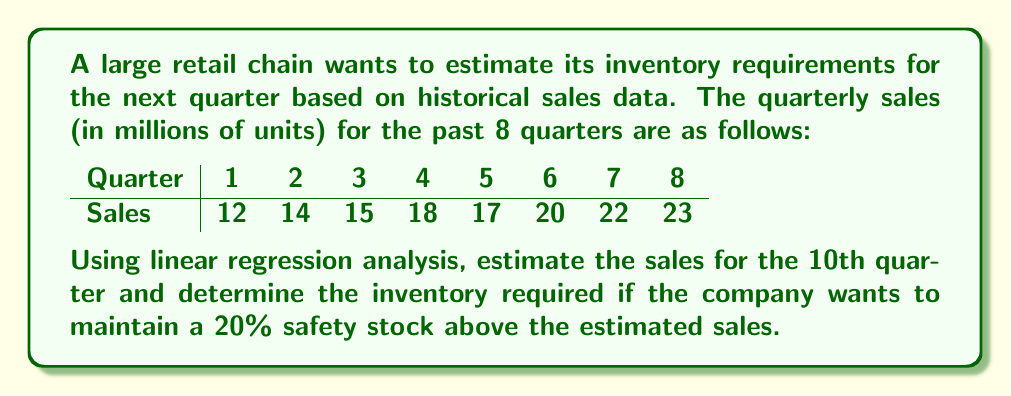Can you solve this math problem? To solve this problem, we'll use linear regression to find the line of best fit for the given data, then use it to estimate future sales.

1. First, let's set up our variables:
   $x$: Quarter number
   $y$: Sales in millions of units

2. We need to calculate the following sums:
   $\sum x = 1 + 2 + 3 + 4 + 5 + 6 + 7 + 8 = 36$
   $\sum y = 12 + 14 + 15 + 18 + 17 + 20 + 22 + 23 = 141$
   $\sum xy = (1)(12) + (2)(14) + (3)(15) + (4)(18) + (5)(17) + (6)(20) + (7)(22) + (8)(23) = 735$
   $\sum x^2 = 1^2 + 2^2 + 3^2 + 4^2 + 5^2 + 6^2 + 7^2 + 8^2 = 204$
   $n = 8$ (number of data points)

3. Use the linear regression formula to find the slope (m) and y-intercept (b):

   $m = \frac{n\sum xy - \sum x \sum y}{n\sum x^2 - (\sum x)^2}$
   
   $m = \frac{8(735) - (36)(141)}{8(204) - 36^2} = \frac{5880 - 5076}{1632 - 1296} = \frac{804}{336} = 2.39286$

   $b = \frac{\sum y - m\sum x}{n} = \frac{141 - 2.39286(36)}{8} = \frac{141 - 86.14286}{8} = 6.85714$

4. The equation of the line of best fit is:
   $y = 2.39286x + 6.85714$

5. To estimate sales for the 10th quarter, substitute $x = 10$:
   $y = 2.39286(10) + 6.85714 = 30.78574$

6. Rounding to the nearest million, the estimated sales for the 10th quarter is 31 million units.

7. To determine the inventory required with a 20% safety stock:
   Inventory = Estimated sales + 20% of estimated sales
   $= 31 + (0.20 * 31) = 31 + 6.2 = 37.2$ million units
Answer: The estimated sales for the 10th quarter is 31 million units, and the required inventory with a 20% safety stock is 37.2 million units. 